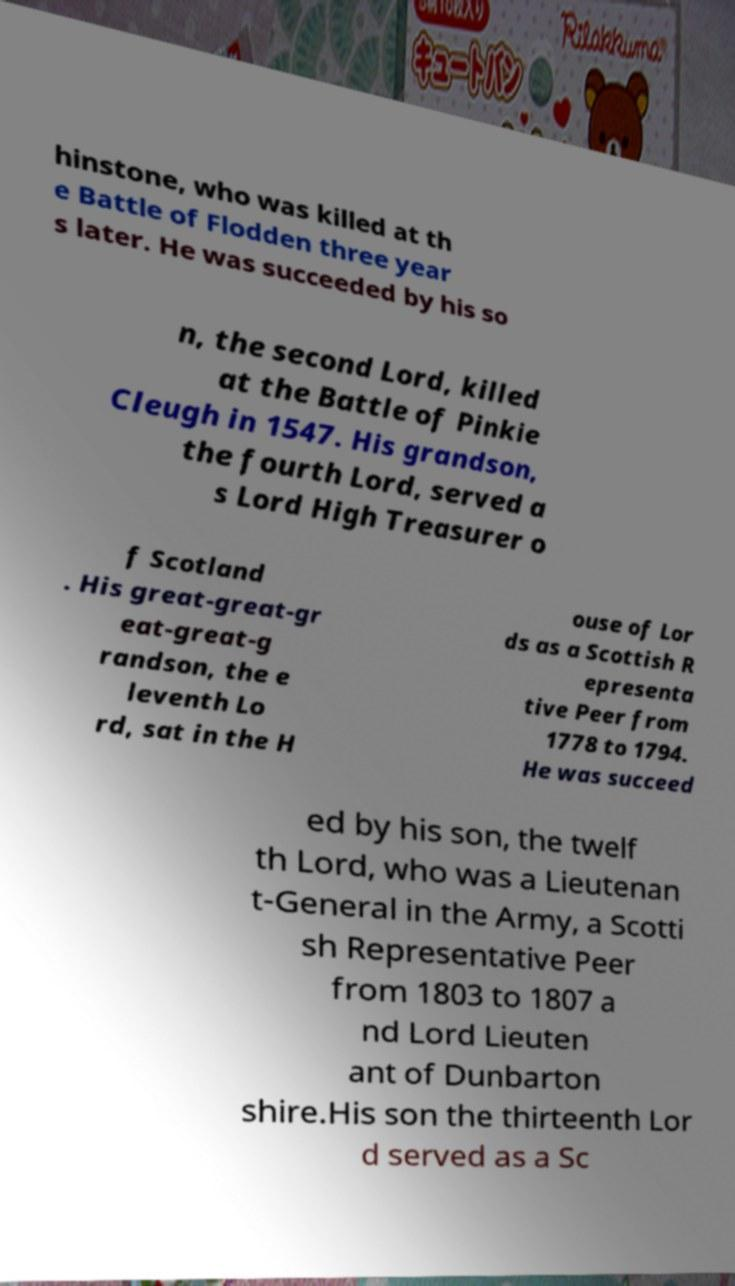Can you read and provide the text displayed in the image?This photo seems to have some interesting text. Can you extract and type it out for me? hinstone, who was killed at th e Battle of Flodden three year s later. He was succeeded by his so n, the second Lord, killed at the Battle of Pinkie Cleugh in 1547. His grandson, the fourth Lord, served a s Lord High Treasurer o f Scotland . His great-great-gr eat-great-g randson, the e leventh Lo rd, sat in the H ouse of Lor ds as a Scottish R epresenta tive Peer from 1778 to 1794. He was succeed ed by his son, the twelf th Lord, who was a Lieutenan t-General in the Army, a Scotti sh Representative Peer from 1803 to 1807 a nd Lord Lieuten ant of Dunbarton shire.His son the thirteenth Lor d served as a Sc 